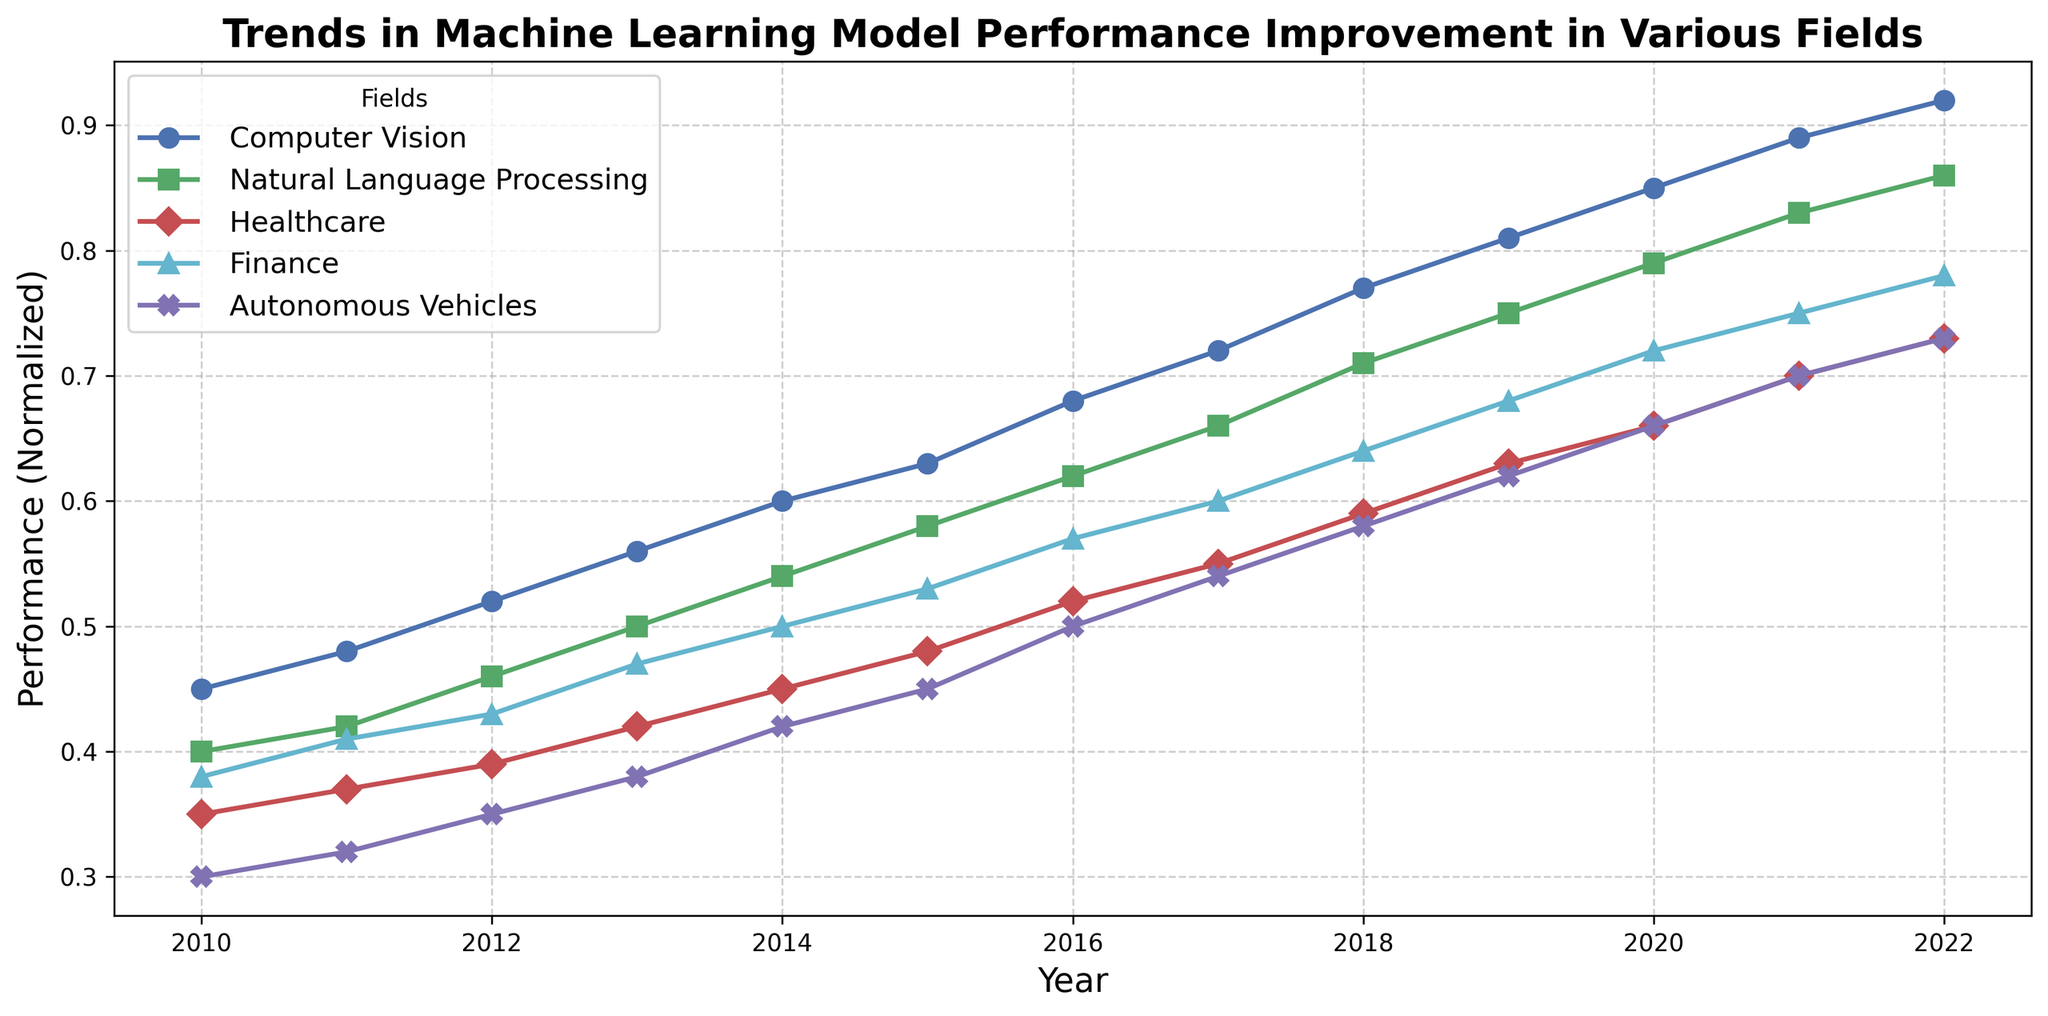What field showed the highest performance improvement in 2022? To find the highest performance improvement in 2022, look at the endpoints of all the lines and identify which one reaches the highest point on the y-axis.
Answer: Computer Vision Between 2011 and 2015, which field had the smallest performance improvement? Calculate the difference in performance values between 2011 and 2015 for each field and compare them. For example, Computer Vision: 0.63 - 0.48 = 0.15, etc.
Answer: Autonomous Vehicles In which year did Natural Language Processing reach a normalized performance of 0.54? Check the year-wise data points corresponding to Natural Language Processing and find the year where the performance is 0.54.
Answer: 2014 By how much did the performance in Healthcare increase from 2010 to 2022? Look at the starting and ending points of the Healthcare line and calculate the difference: 0.73 - 0.35
Answer: 0.38 Which field had the most consistent year-over-year improvement in performance? Visualize the smoothness and uniformity of the incremental steps in the plotted lines. The line with fewer fluctuations is the most consistent.
Answer: Computer Vision What's the average normalized performance of Finance from 2010 to 2022? Calculate the average by summing up all the performance values of Finance from 2010 to 2022 and dividing by the number of years: (0.38 + 0.41 + 0.43 + 0.47 + 0.50 + 0.53 + 0.57 + 0.60 + 0.64 + 0.68 + 0.72 + 0.75 + 0.78) / 13
Answer: 0.58 Which field showed a sudden increase in performance between 2017 and 2018? Compare the slopes between 2017 and 2018 for all fields and identify which line has the steepest rise.
Answer: Natural Language Processing What is the relative performance gap between Finance and Healthcare in 2022? Subtract the performance value of Finance from Healthcare at the year 2022: 0.78 - 0.73
Answer: 0.05 Which field reached a normalized performance of 0.85 first, and in what year? Look at the lines and find when Computer Vision first reaches the point 0.85 on the y-axis, which occurs in 2020.
Answer: Computer Vision in 2020 